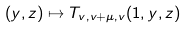<formula> <loc_0><loc_0><loc_500><loc_500>( y , z ) \mapsto T _ { v , v + \mu , v } ( 1 , y , z )</formula> 